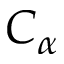Convert formula to latex. <formula><loc_0><loc_0><loc_500><loc_500>C _ { \alpha }</formula> 